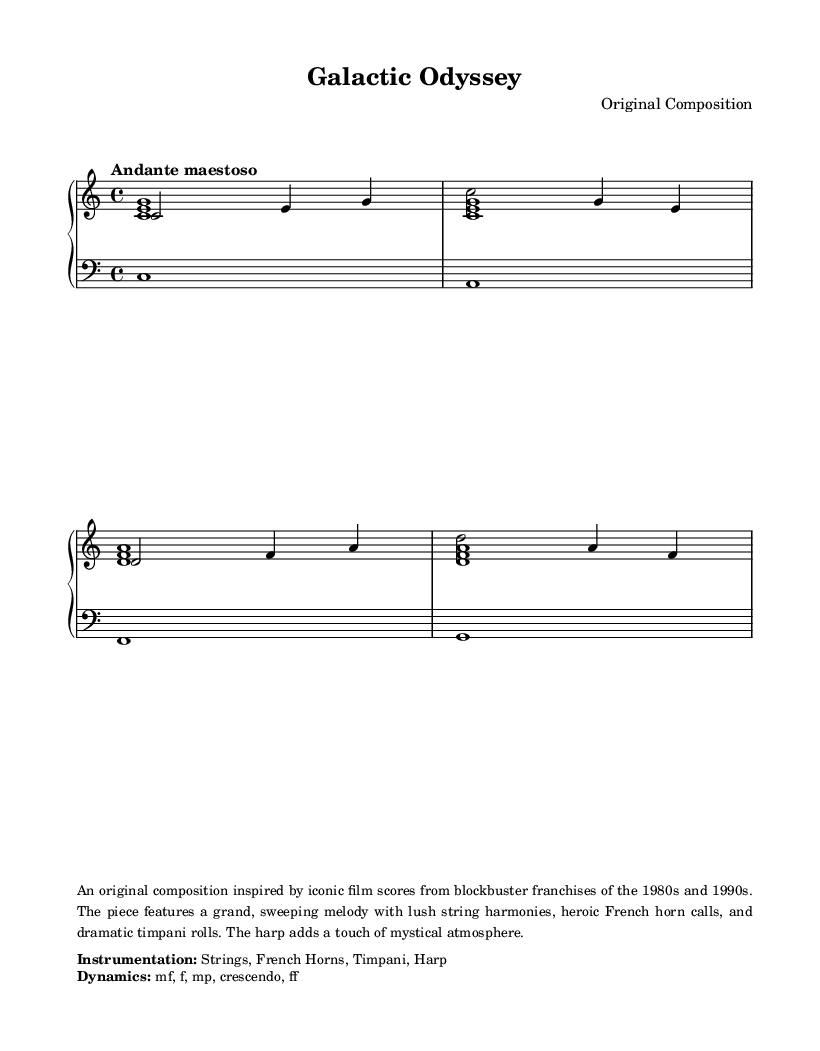What is the key signature of this music? The key signature is indicated at the beginning of the staff with the "c" symbol, indicating C major, which has no sharps or flats.
Answer: C major What is the time signature of this music? The time signature is found right after the key signature. In this case, it shows "4/4", meaning there are four beats per measure and the quarter note gets the beat.
Answer: 4/4 What is the tempo indication of this piece? The tempo marking appears above the music staff; it states "Andante maestoso," which describes the intended speed and style of the piece.
Answer: Andante maestoso What instruments are specified in the instrumentation? The instrumentation can be found in the markup section, which specifically lists the instruments used in the piece: Strings, French Horns, Timpani, Harp.
Answer: Strings, French Horns, Timpani, Harp How many measures are in the upper staff? By counting the individual measure bars in the upper staff section, it reveals there are four measures presented in total within the score.
Answer: 4 What dynamic marking is indicated for this piece? The dynamic instructions are provided in the markup section, calling out various dynamics including "mf, f, mp, crescendo, ff," which specify the volume levels intended throughout the piece.
Answer: mf, f, mp, crescendo, ff What type of piece is "Galactic Odyssey" described as? The description in the markup characterizes the piece as an "original composition inspired by iconic film scores from blockbuster franchises of the 1980s and 1990s."
Answer: Original composition 